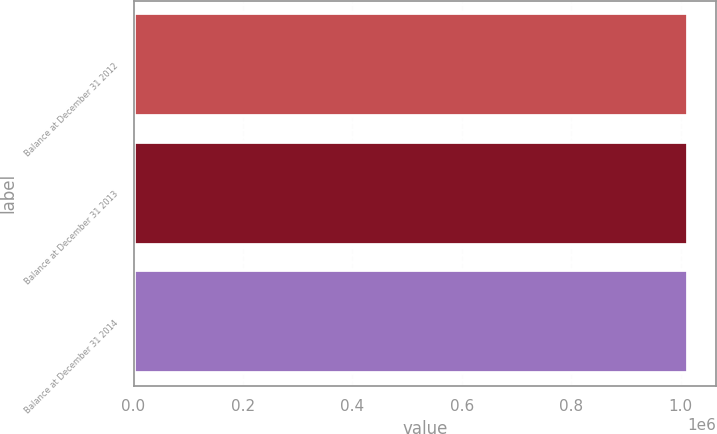Convert chart to OTSL. <chart><loc_0><loc_0><loc_500><loc_500><bar_chart><fcel>Balance at December 31 2012<fcel>Balance at December 31 2013<fcel>Balance at December 31 2014<nl><fcel>1.01413e+06<fcel>1.01413e+06<fcel>1.01413e+06<nl></chart> 